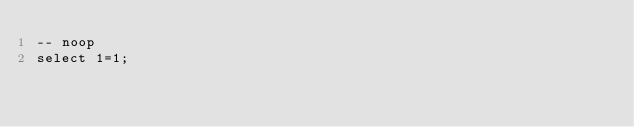<code> <loc_0><loc_0><loc_500><loc_500><_SQL_>-- noop
select 1=1;
</code> 